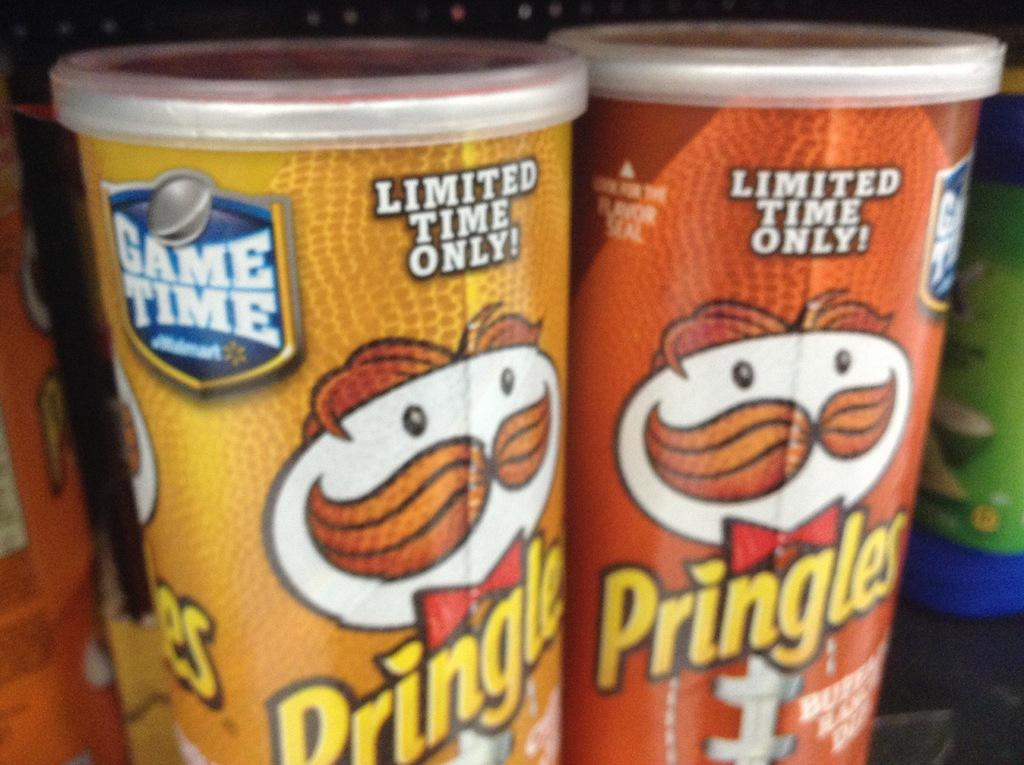Provide a one-sentence caption for the provided image. two different colored pringles cans, one is yellow, one brown. 